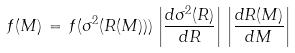Convert formula to latex. <formula><loc_0><loc_0><loc_500><loc_500>f ( M ) \, = \, f ( \sigma ^ { 2 } ( R ( M ) ) ) \, \left | \frac { d \sigma ^ { 2 } ( R ) } { d R } \right | \, \left | \frac { d R ( M ) } { d M } \right |</formula> 